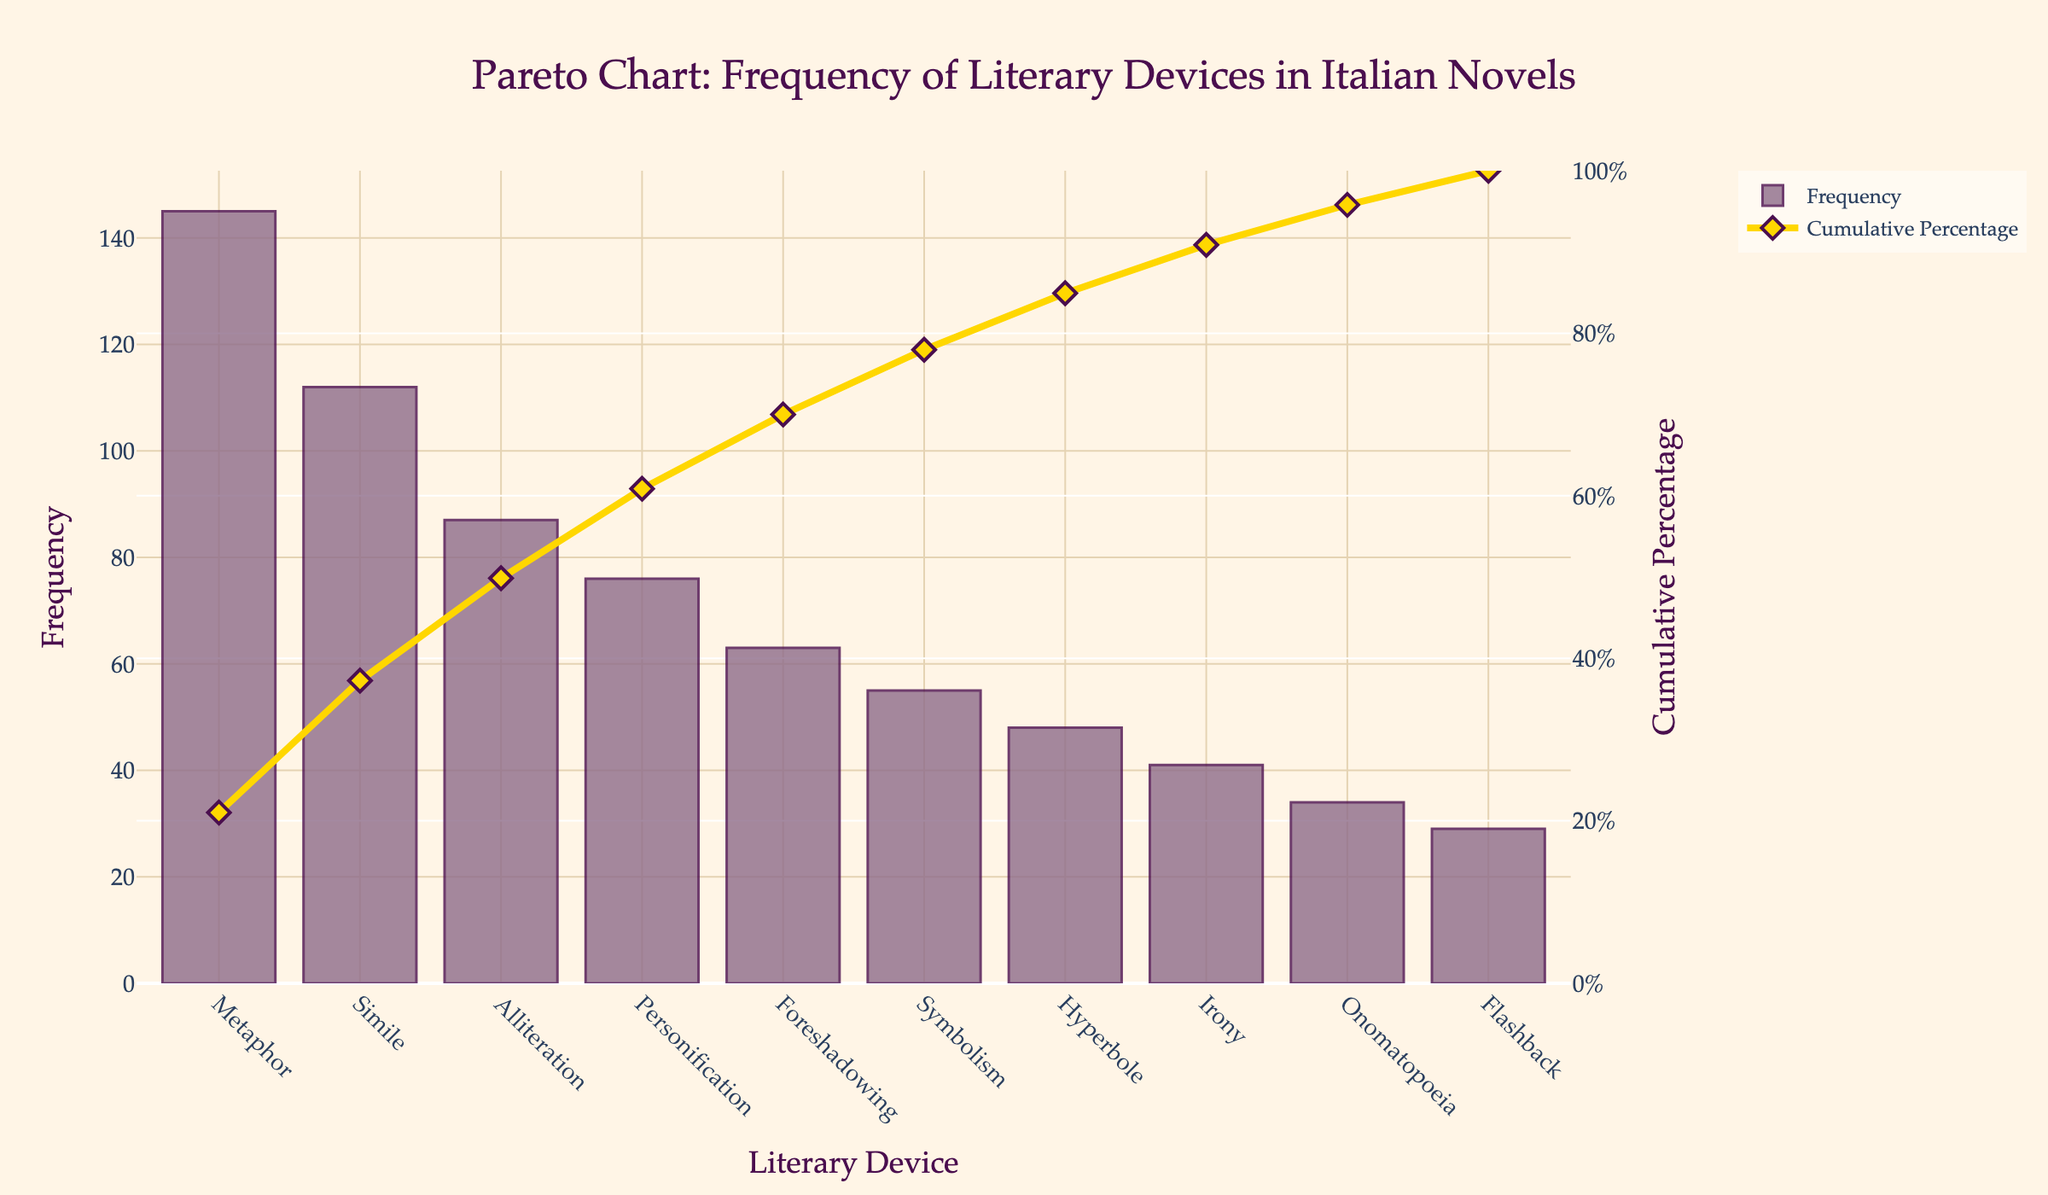What is the most frequently used literary device? The most frequently used literary device is represented by the tallest bar in the bar chart. By identifying the highest bar, we can see that 'Metaphor' is the most frequently used literary device with a frequency of 145.
Answer: Metaphor What is the title of the figure? The title of the figure is typically located at the top center of the chart, providing an overview of what the chart is about. The title of the figure is 'Pareto Chart: Frequency of Literary Devices in Italian Novels'.
Answer: Pareto Chart: Frequency of Literary Devices in Italian Novels How many literary devices are represented in the chart? To find out how many literary devices are represented, count the number of unique bars on the x-axis of the bar chart. Each bar corresponds to a different literary device. There are 10 bars, thus 10 literary devices are represented.
Answer: 10 Which two literary devices combined account for over 50% of the total frequency? To determine which two literary devices combined exceed 50%, we need to check the cumulative percentage next to each literary device until we surpass 50%. By observing the cumulative percentage line, we see that 'Metaphor' and 'Simile' combined account for a cumulative percentage of 56.38%.
Answer: Metaphor and Simile What is the cumulative percentage for 'Foreshadowing'? The cumulative percentage for 'Foreshadowing' can be found by locating 'Foreshadowing' on the x-axis and tracing upwards to the cumulative percentage line. The cumulative percentage for 'Foreshadowing' is approximately 75.34%.
Answer: 75.34% Which literary device has the smallest frequency and what is its value? The smallest frequency corresponds to the shortest bar in the bar chart. By identifying the lowest bar, we see that 'Flashback' has the smallest frequency, which is 29.
Answer: Flashback with a frequency of 29 How do the frequencies of 'Alliteration' and 'Irony' compare? Compare the heights of the bars corresponding to 'Alliteration' and 'Irony'. 'Alliteration' has a frequency of 87, while 'Irony' has a frequency of 41. Hence, 'Alliteration' is more frequent than 'Irony'.
Answer: Alliteration is more frequent than Irony What are the cumulative percentages for the first three literary devices? The first three literary devices in decreasing order of frequency are 'Metaphor', 'Simile', and 'Alliteration'. The cumulative percentages for these devices are approximately 22.07%, 36.13%, and 49.37% respectively.
Answer: 22.07%, 36.13%, and 49.37% Which literary device has a cumulative percentage closest to 90%? Locate the cumulative percentage line and identify the device closest to the 90% mark. 'Onomatopoeia' has a cumulative percentage of approximately 91.46%, which is the closest to 90%.
Answer: Onomatopoeia 